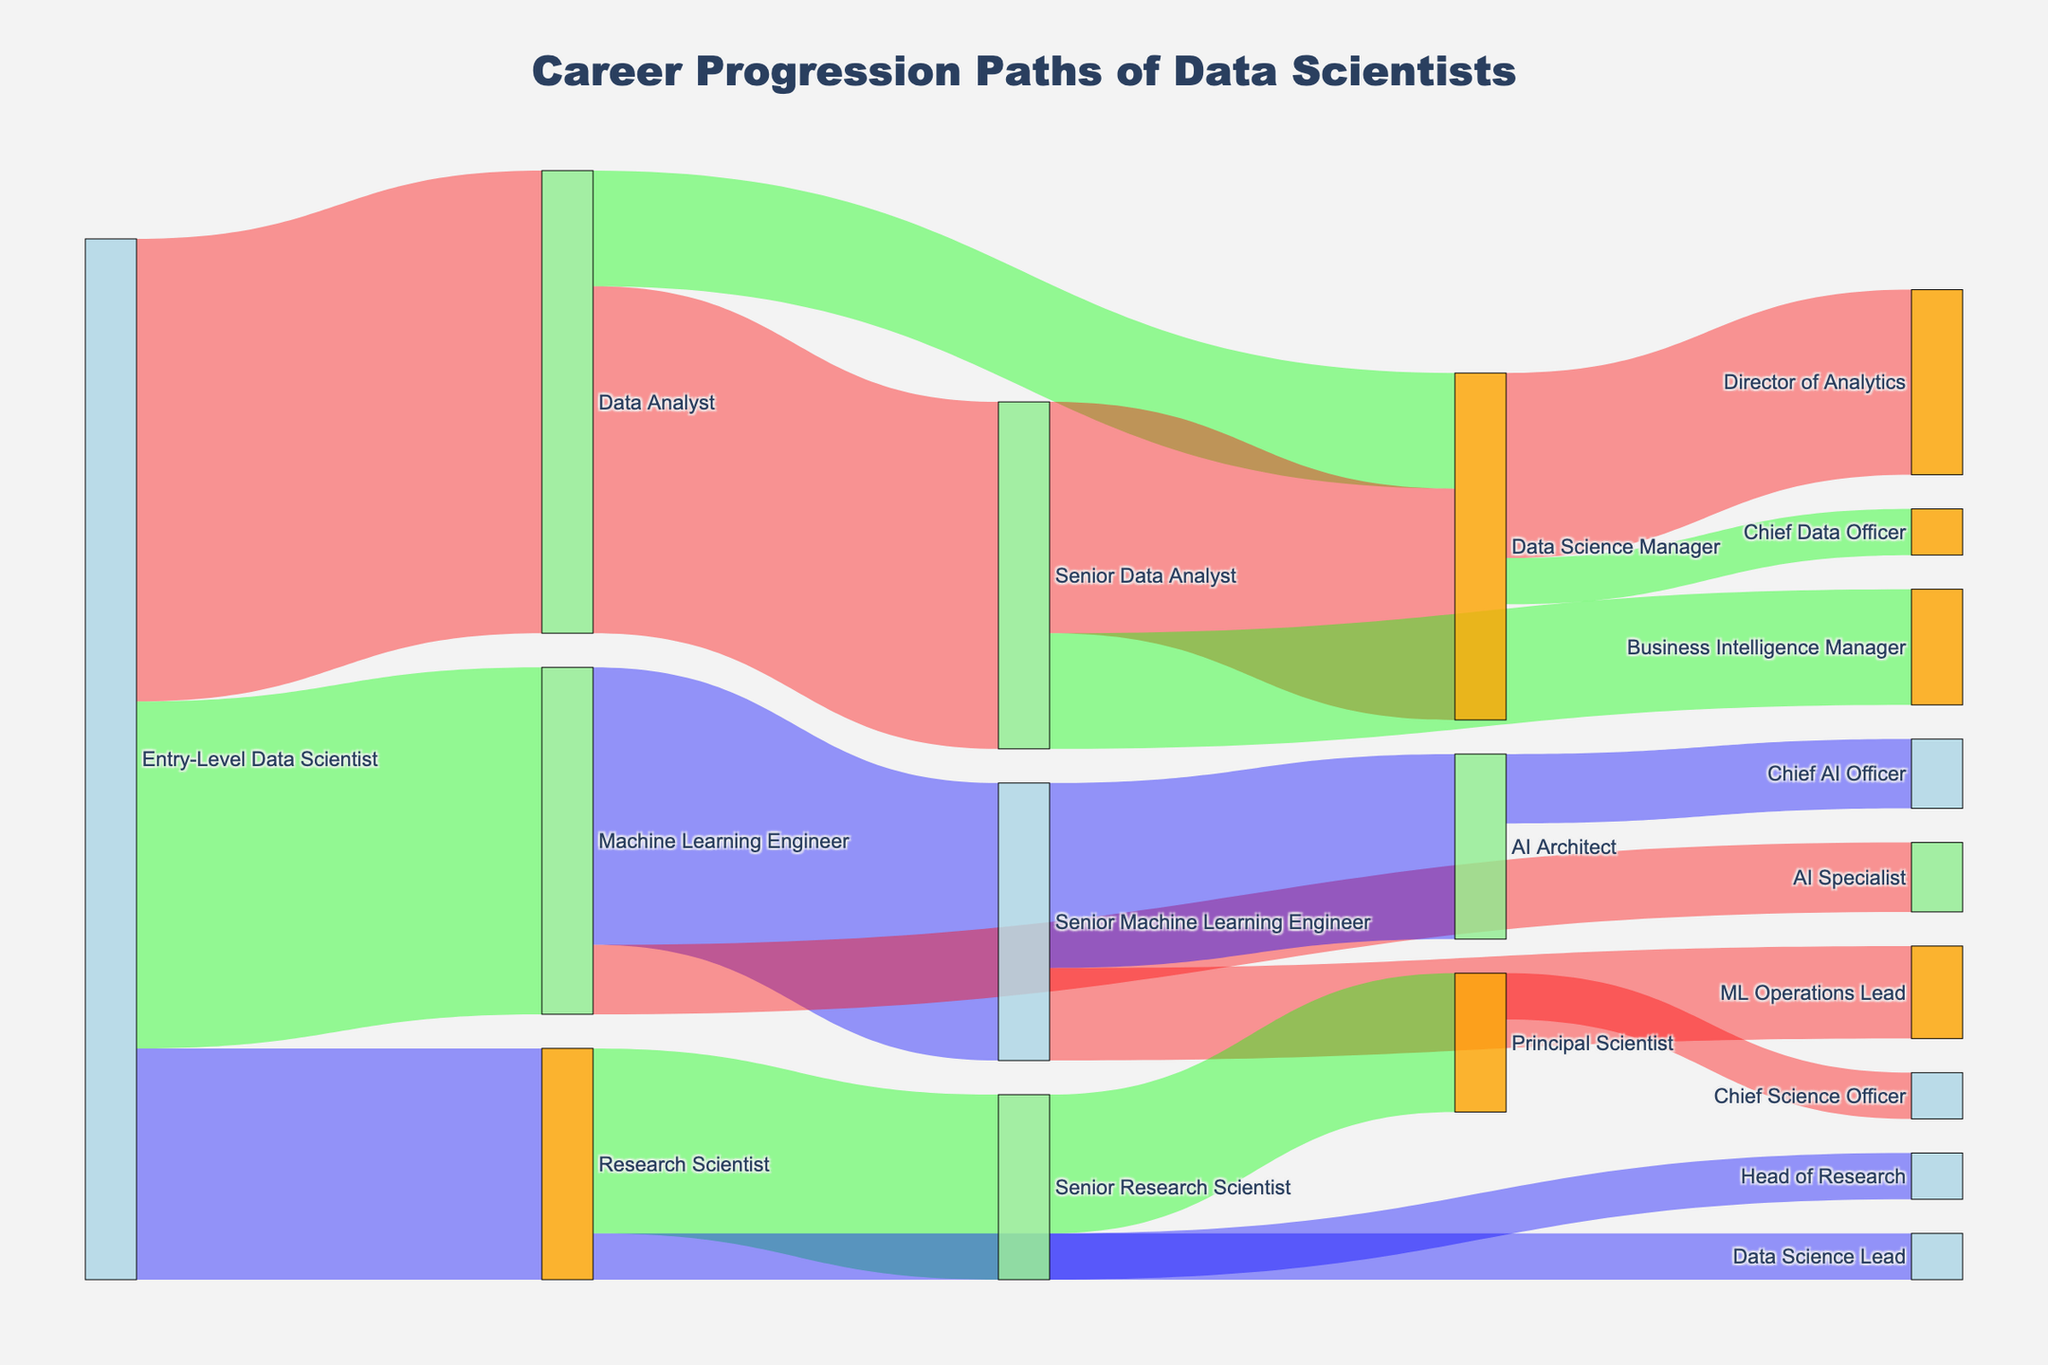What is the most common career progression for an entry-level data scientist? The most common career progression is identified by the pathway with the highest value stemming from the "Entry-Level Data Scientist" node. The highest value is 20, leading to "Data Analyst."
Answer: Data Analyst How many data scientists advance to senior roles directly from the entry-level position? Identify all paths originating from "Entry-Level Data Scientist" with a "Senior" role in the target node. There are none directly leading to a "Senior" designation; all intermediate roles do not have a "Senior" designation.
Answer: 0 Which position has the most outgoing transitions into other roles? Count the number of outgoing transitions from each node. "Entry-Level Data Scientist" has three transitions (to "Data Analyst," "Machine Learning Engineer," "Research Scientist"), "Data Analyst" has two transitions, and so on. "Entry-Level Data Scientist" has the most.
Answer: Entry-Level Data Scientist Does the role of Data Science Manager lead more often to Director of Analytics or Chief Data Officer? Compare the values of transitions from "Data Science Manager." The transition value to "Director of Analytics" is 8 and to "Chief Data Officer" is 2.
Answer: Director of Analytics What is the total number of career transitions from Machine Learning Engineer roles? Sum up the values of all transitions from "Machine Learning Engineer" and "Senior Machine Learning Engineer" nodes. They are 15 (from entry-level), 12 (to senior), 3 (to AI Specialist), 8 (AI Architect), 4 (ML Operations Lead). The total is 42.
Answer: 42 Which senior role in data science has the fewest advancements to executive positions? Identify the outgoing transitions leading to executive roles and compare their values. "Senior Research Scientist" has a transition to "Head of Research" (2) and "Principal Scientist" (6); only "Chief Science Officer" has the lowest transition value of 2 from "Principal Scientist."
Answer: Chief Science Officer What role does a Principal Scientist frequently advance to? Identify the outgoing transition from "Principal Scientist." The only transition is to "Chief Science Officer" with a value of 2.
Answer: Chief Science Officer 